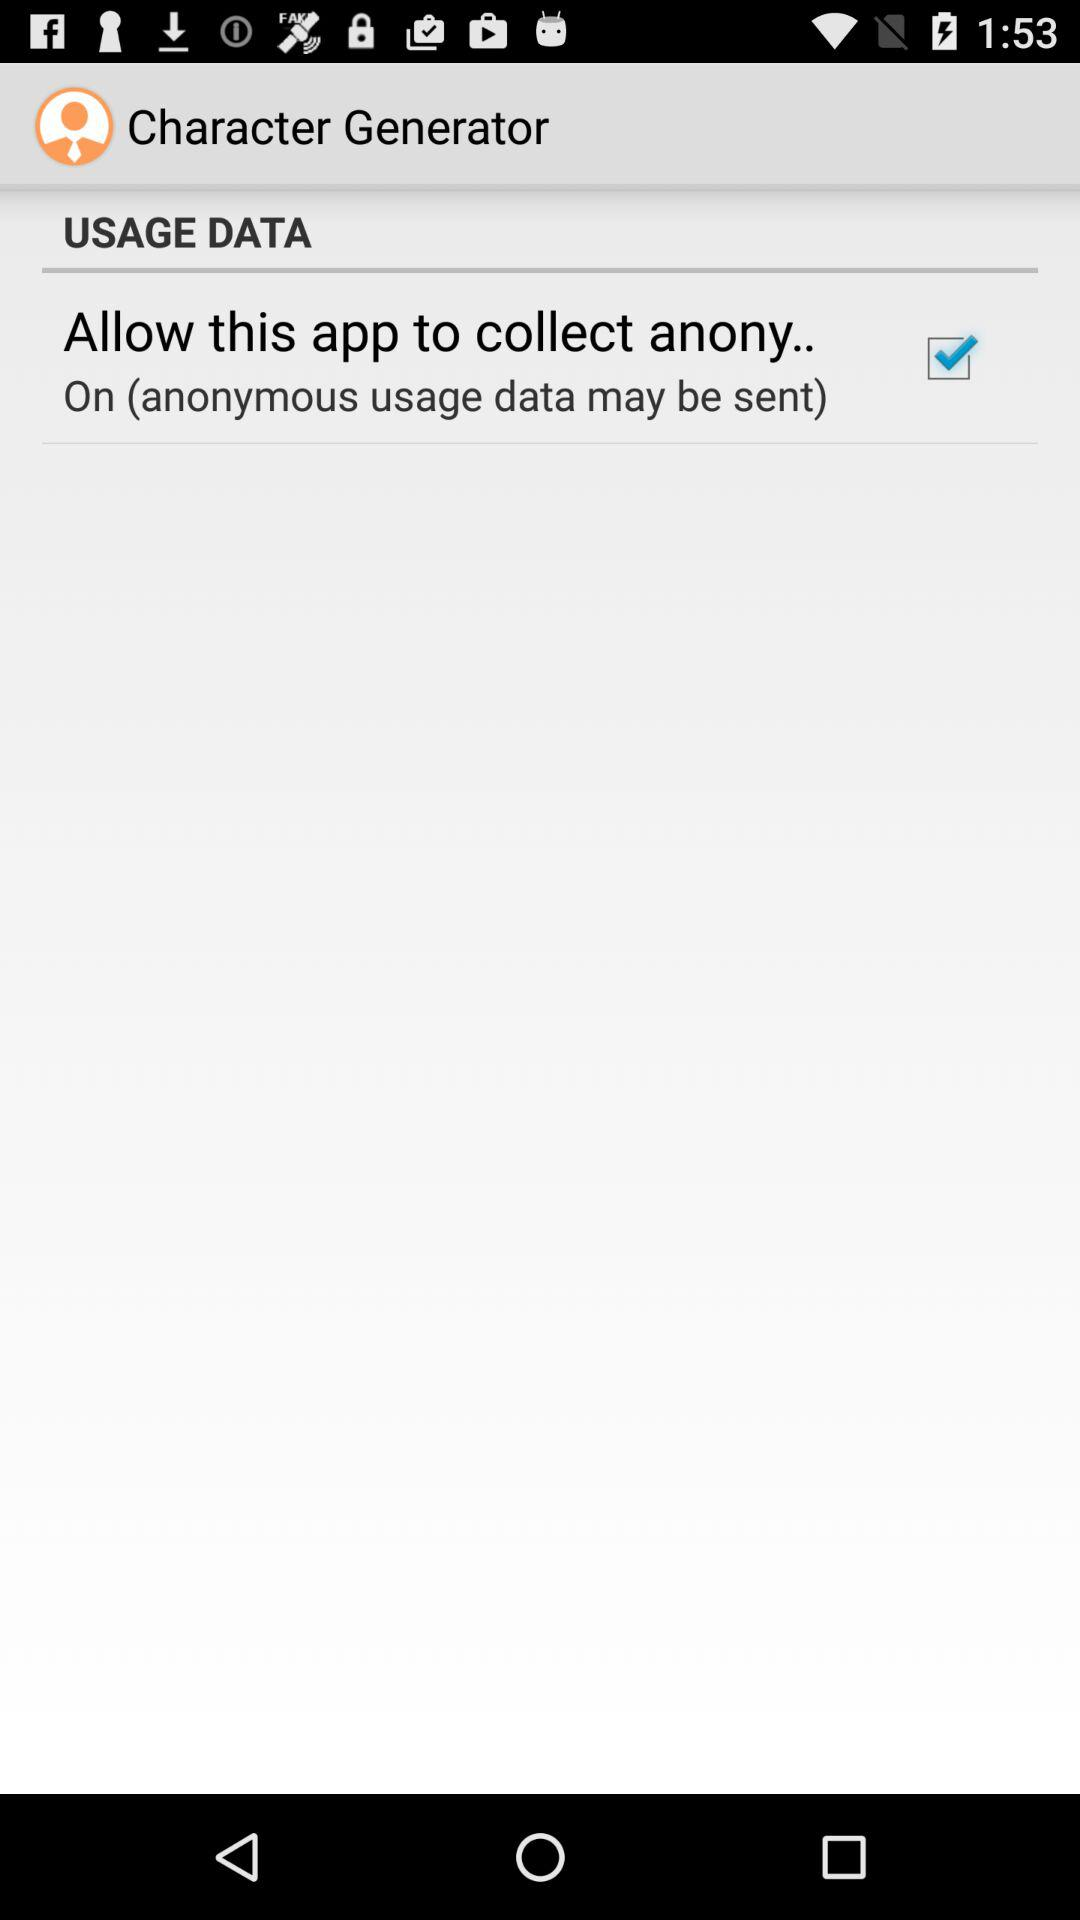Which option has been checked? The checked option is "Allow this app to collect anony..". 